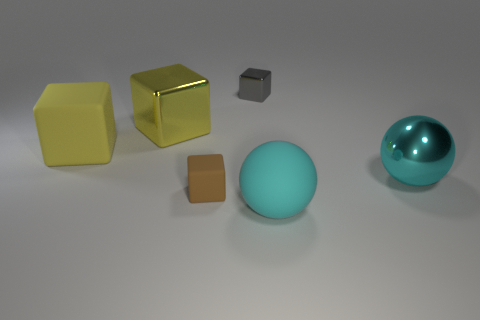Subtract all red blocks. Subtract all cyan cylinders. How many blocks are left? 4 Add 2 green blocks. How many objects exist? 8 Subtract all spheres. How many objects are left? 4 Add 1 green metal cylinders. How many green metal cylinders exist? 1 Subtract 0 purple blocks. How many objects are left? 6 Subtract all red matte balls. Subtract all gray metallic objects. How many objects are left? 5 Add 1 blocks. How many blocks are left? 5 